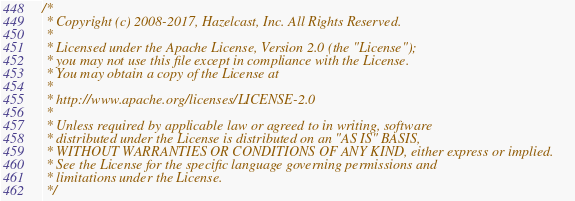Convert code to text. <code><loc_0><loc_0><loc_500><loc_500><_Java_>/*
 * Copyright (c) 2008-2017, Hazelcast, Inc. All Rights Reserved.
 *
 * Licensed under the Apache License, Version 2.0 (the "License");
 * you may not use this file except in compliance with the License.
 * You may obtain a copy of the License at
 *
 * http://www.apache.org/licenses/LICENSE-2.0
 *
 * Unless required by applicable law or agreed to in writing, software
 * distributed under the License is distributed on an "AS IS" BASIS,
 * WITHOUT WARRANTIES OR CONDITIONS OF ANY KIND, either express or implied.
 * See the License for the specific language governing permissions and
 * limitations under the License.
 */
</code> 